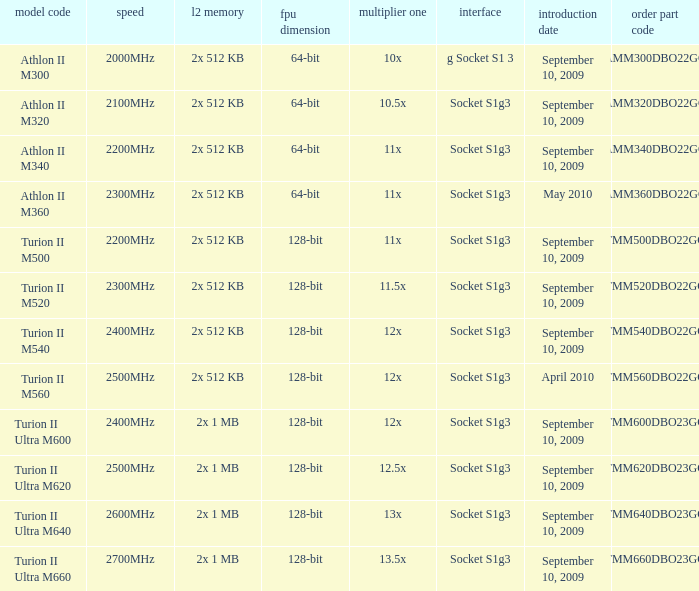What is the frequency of the tmm500dbo22gq order part number? 2200MHz. 